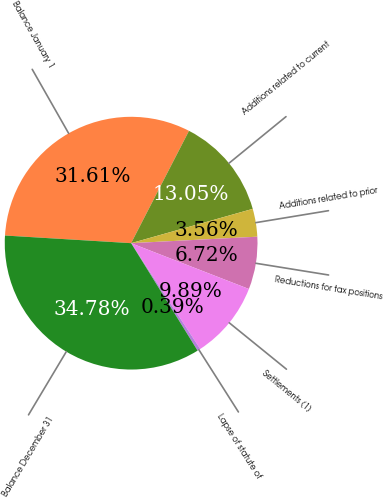Convert chart to OTSL. <chart><loc_0><loc_0><loc_500><loc_500><pie_chart><fcel>Balance January 1<fcel>Additions related to current<fcel>Additions related to prior<fcel>Reductions for tax positions<fcel>Settlements (1)<fcel>Lapse of statute of<fcel>Balance December 31<nl><fcel>31.61%<fcel>13.05%<fcel>3.56%<fcel>6.72%<fcel>9.89%<fcel>0.39%<fcel>34.78%<nl></chart> 